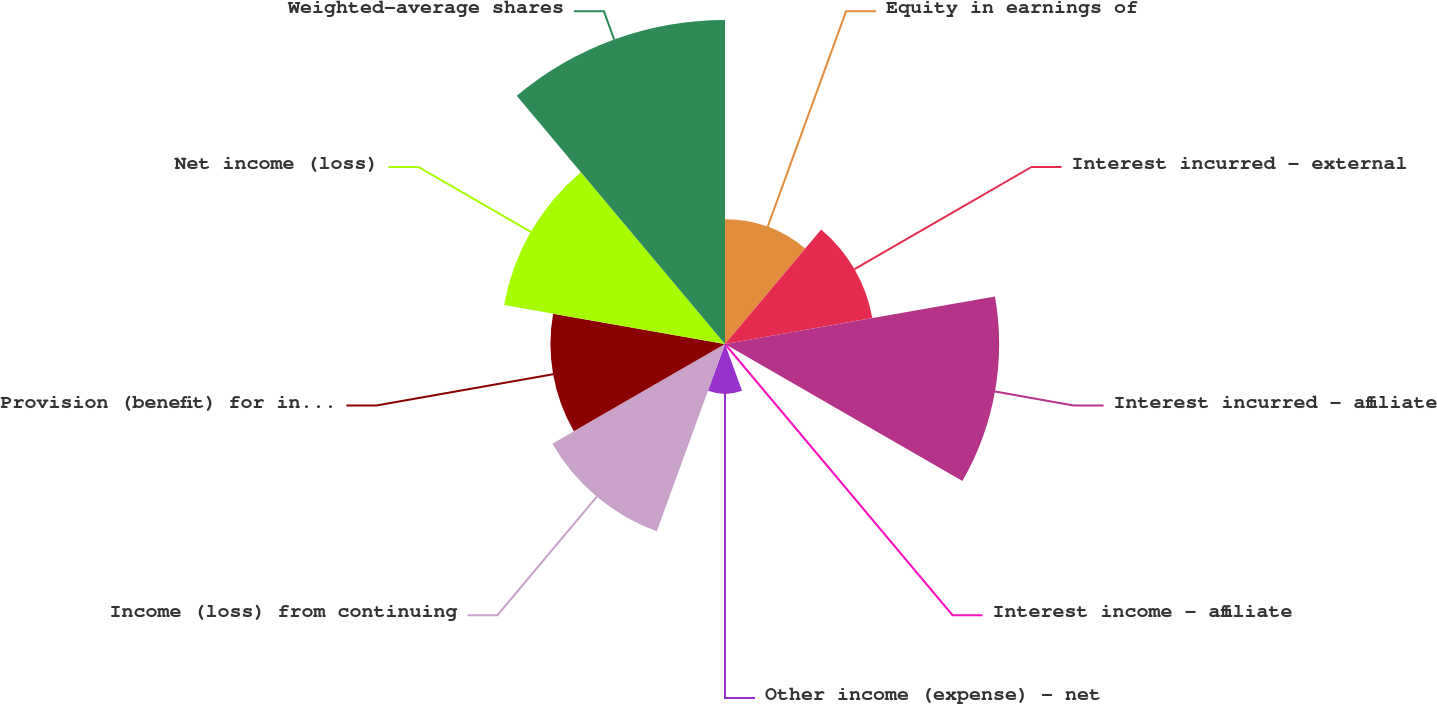Convert chart to OTSL. <chart><loc_0><loc_0><loc_500><loc_500><pie_chart><fcel>Equity in earnings of<fcel>Interest incurred - external<fcel>Interest incurred - affiliate<fcel>Interest income - affiliate<fcel>Other income (expense) - net<fcel>Income (loss) from continuing<fcel>Provision (benefit) for income<fcel>Net income (loss)<fcel>Weighted-average shares<nl><fcel>8.2%<fcel>9.84%<fcel>18.03%<fcel>0.0%<fcel>3.28%<fcel>13.11%<fcel>11.48%<fcel>14.75%<fcel>21.31%<nl></chart> 